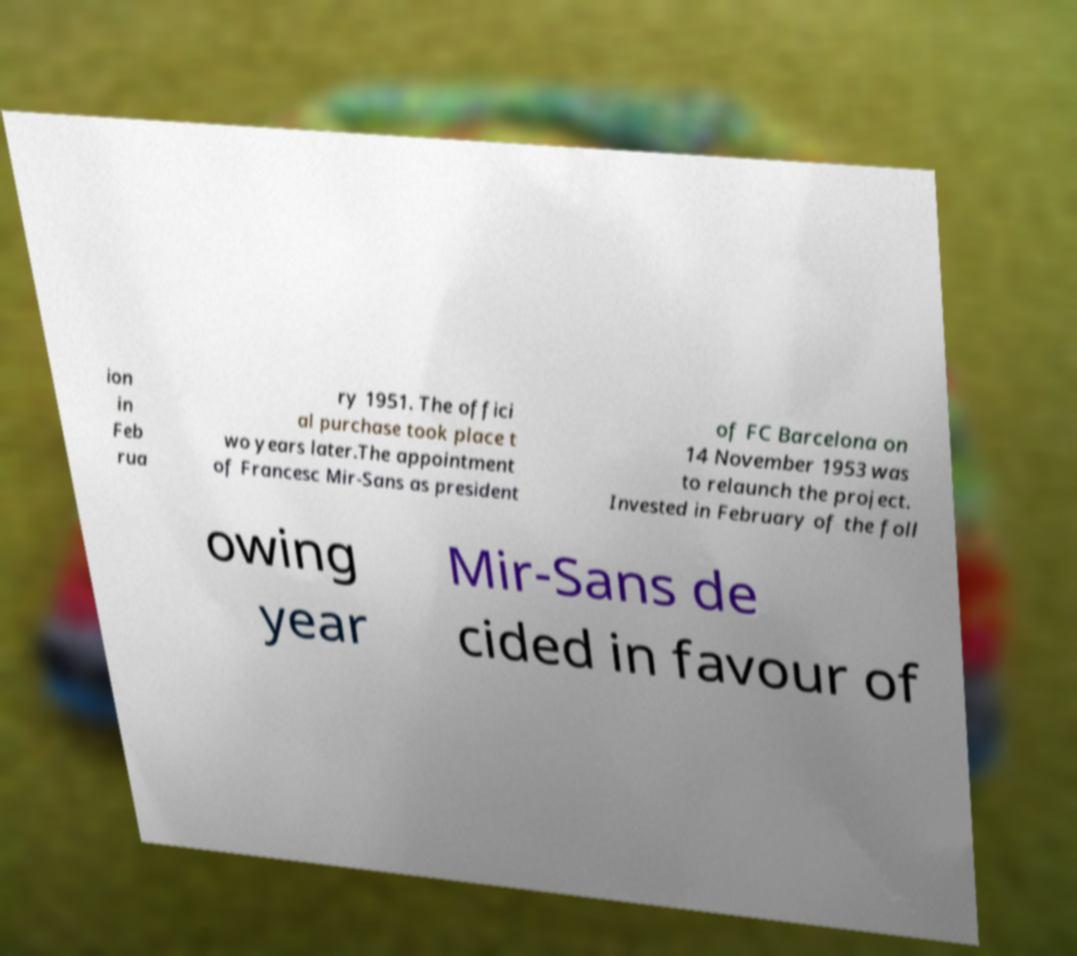Please read and relay the text visible in this image. What does it say? ion in Feb rua ry 1951. The offici al purchase took place t wo years later.The appointment of Francesc Mir-Sans as president of FC Barcelona on 14 November 1953 was to relaunch the project. Invested in February of the foll owing year Mir-Sans de cided in favour of 